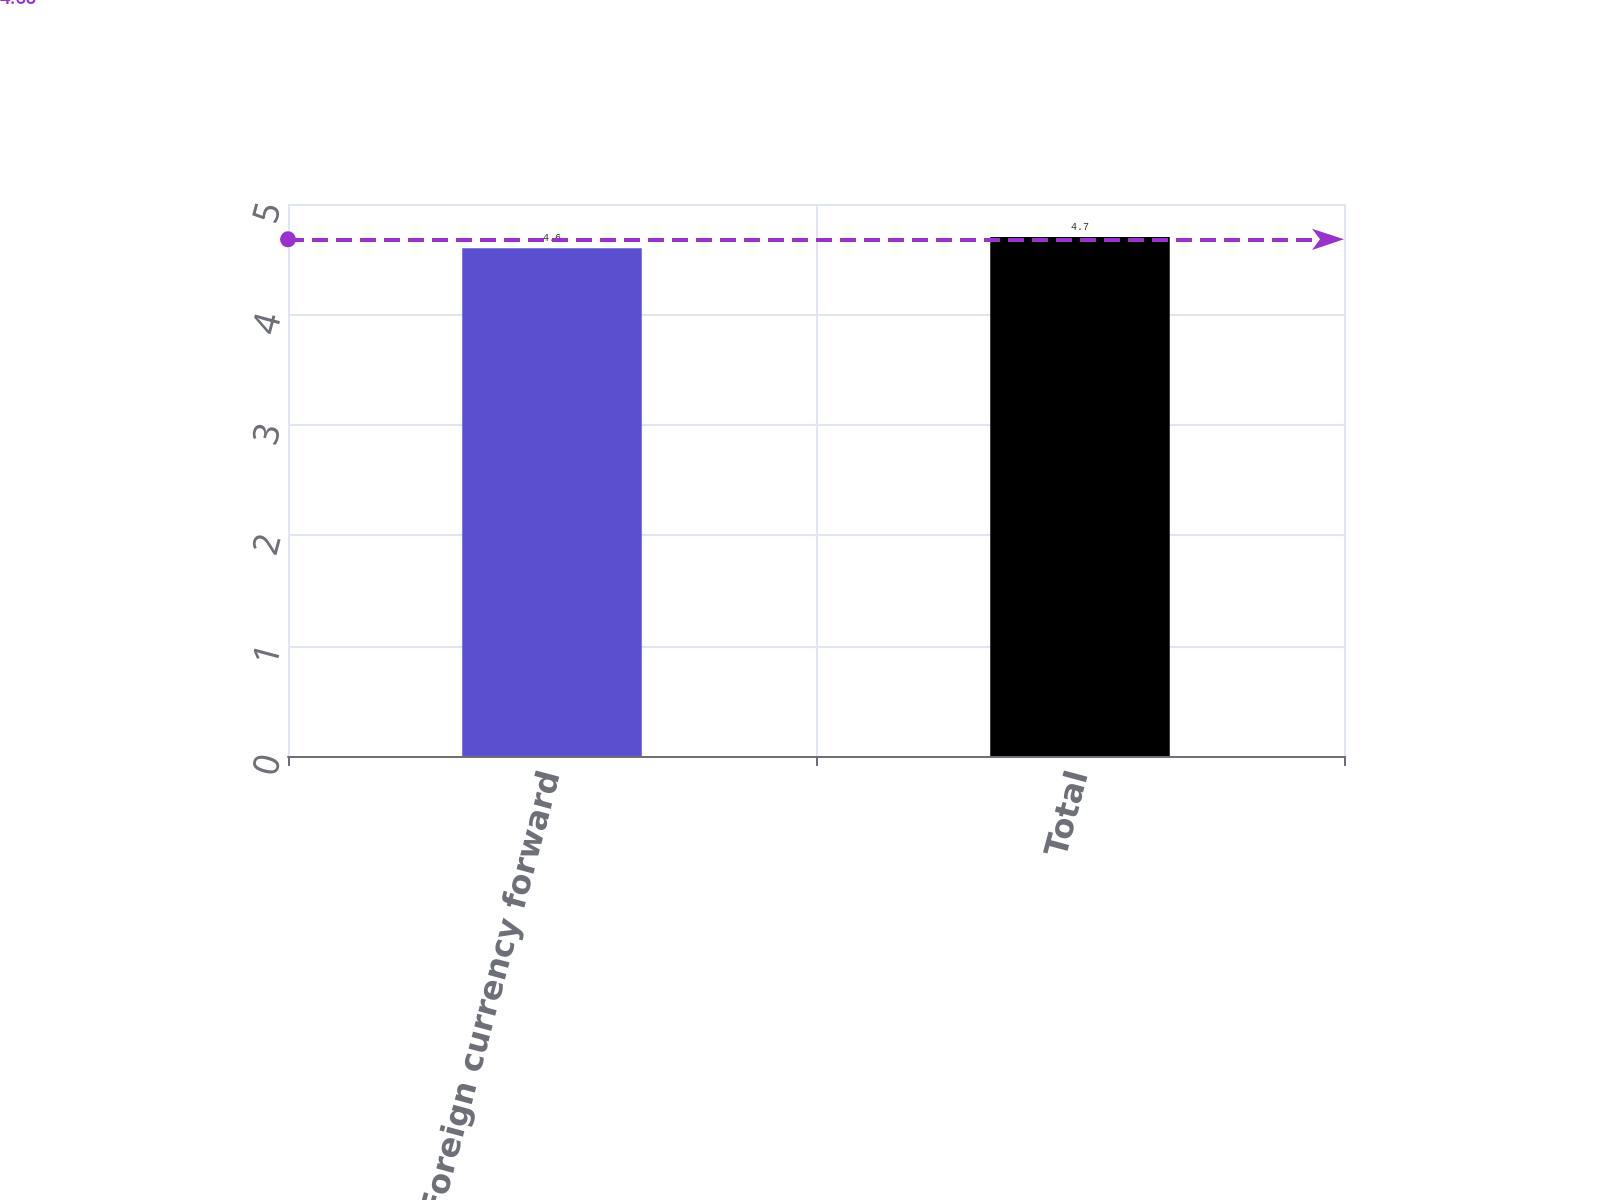<chart> <loc_0><loc_0><loc_500><loc_500><bar_chart><fcel>Foreign currency forward<fcel>Total<nl><fcel>4.6<fcel>4.7<nl></chart> 